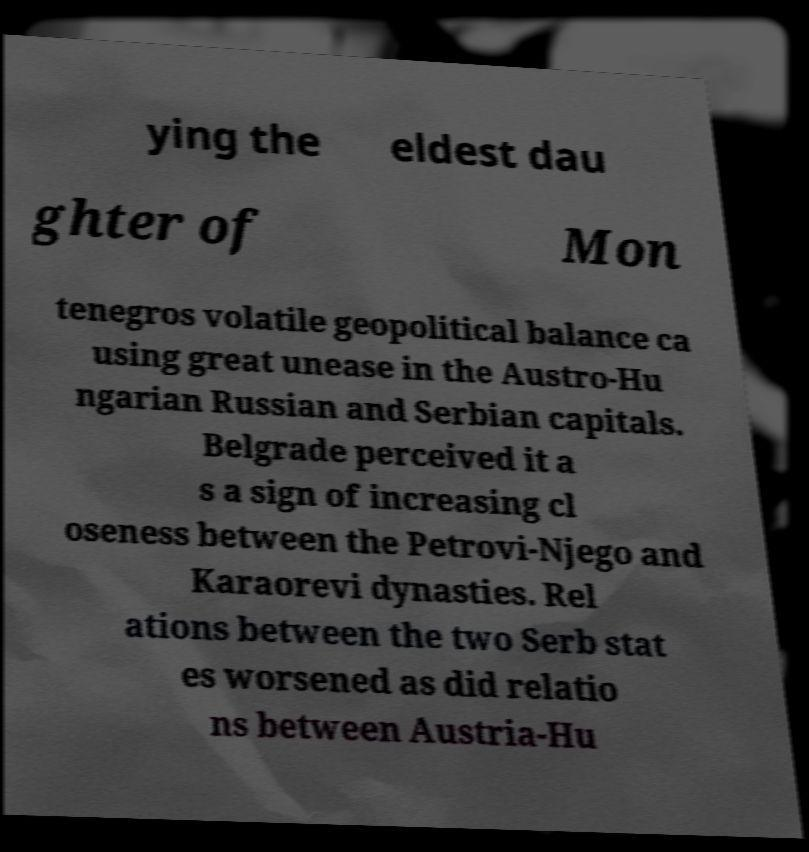There's text embedded in this image that I need extracted. Can you transcribe it verbatim? ying the eldest dau ghter of Mon tenegros volatile geopolitical balance ca using great unease in the Austro-Hu ngarian Russian and Serbian capitals. Belgrade perceived it a s a sign of increasing cl oseness between the Petrovi-Njego and Karaorevi dynasties. Rel ations between the two Serb stat es worsened as did relatio ns between Austria-Hu 